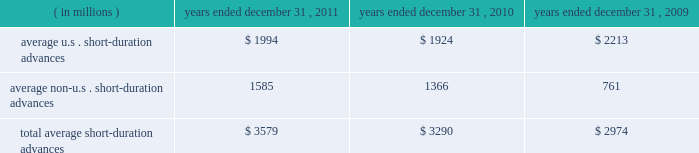Average securities purchased under resale agreements increased to $ 4.69 billion for the year ended december 31 , 2011 from $ 2.96 billion for the year ended december 31 , 2010 .
Average trading account assets increased to $ 2.01 billion for the year ended december 31 , 2011 from $ 376 million for 2010 .
Averages benefited largely from an increase in client demand associated with our trading activities .
In connection with these activities , we traded in highly liquid fixed-income securities as principal with our custody clients and other third- parties that trade in these securities .
Our average investment securities portfolio increased to $ 103.08 billion for the year ended december 31 , 2011 from $ 96.12 billion for 2010 .
The increase was generally the result of ongoing purchases of securities , partly offset by maturities and sales .
In december 2010 , we repositioned our portfolio by selling approximately $ 11 billion of mortgage- and asset-backed securities and re-investing approximately $ 7 billion of the proceeds , primarily in agency mortgage-backed securities .
The repositioning was undertaken to enhance our regulatory capital ratios under evolving regulatory capital standards , increase our balance sheet flexibility in deploying our capital , and reduce our exposure to certain asset classes .
During 2011 , we purchased $ 54 billion of highly rated u.s .
Treasury securities , federal agency mortgage-backed securities and u.s .
And non-u.s .
Asset-backed securities .
As of december 31 , 2011 , securities rated 201caaa 201d and 201caa 201d comprised approximately 89% ( 89 % ) of our portfolio , compared to 90% ( 90 % ) rated 201caaa 201d and 201caa 201d as of december 31 , 2010 .
Loans and leases averaged $ 12.18 billion for the year ended december 31 , 2011 , compared to $ 12.09 billion for 2010 .
The increases primarily resulted from higher client demand for short-duration liquidity , offset in part by a decrease in leases and the purchased receivables added in connection with the conduit consolidation , mainly from maturities and pay-downs .
For 2011 and 2010 , approximately 29% ( 29 % ) and 27% ( 27 % ) , respectively , of our average loan and lease portfolio was composed of short-duration advances that provided liquidity to clients in support of their investment activities related to securities settlement .
The table presents average u.s .
And non-u.s .
Short-duration advances for the years indicated: .
For the year ended december 31 , 2011 , the increase in average non-u.s .
Short-duration advances compared to the prior-year period was mainly due to activity associated with clients added in connection with the acquired intesa securities services business .
Average other interest-earning assets increased to $ 5.46 billion for the year ended december 31 , 2011 from $ 1.16 billion for 2010 .
The increase was primarily the result of higher levels of cash collateral provided in connection with our role as principal in certain securities borrowing activities .
Average interest-bearing deposits increased to $ 88.06 billion for the year ended december 31 , 2011 from $ 76.96 billion for 2010 .
The increase reflected client deposits added in connection with the may 2010 acquisition of the intesa securities services business , and higher levels of non-u.s .
Transaction accounts associated with new and existing business in assets under custody and administration .
Average other short-term borrowings declined to $ 5.13 billion for the year ended december 31 , 2011 from $ 13.59 billion for 2010 , as the higher levels of client deposits provided additional liquidity .
Average long-term debt increased to $ 8.97 billion for the year ended december 31 , 2011 from $ 8.68 billion for the same period in 2010 .
The increase primarily reflected the issuance of an aggregate of $ 2 billion of senior notes by us in march 2011 , partly offset by the maturities of $ 1 billion of senior notes in february 2011 and $ 1.45 billion of senior notes in september 2011 , both previously issued by state street bank under the fdic 2019s temporary liquidity guarantee program .
Additional information about our long-term debt is provided in note 9 to the consolidated financial statements included under item 8. .
What is the net change in loans and leases in 2011 , ( in billions ) ? 
Computations: (12.18 - 12.09)
Answer: 0.09. 